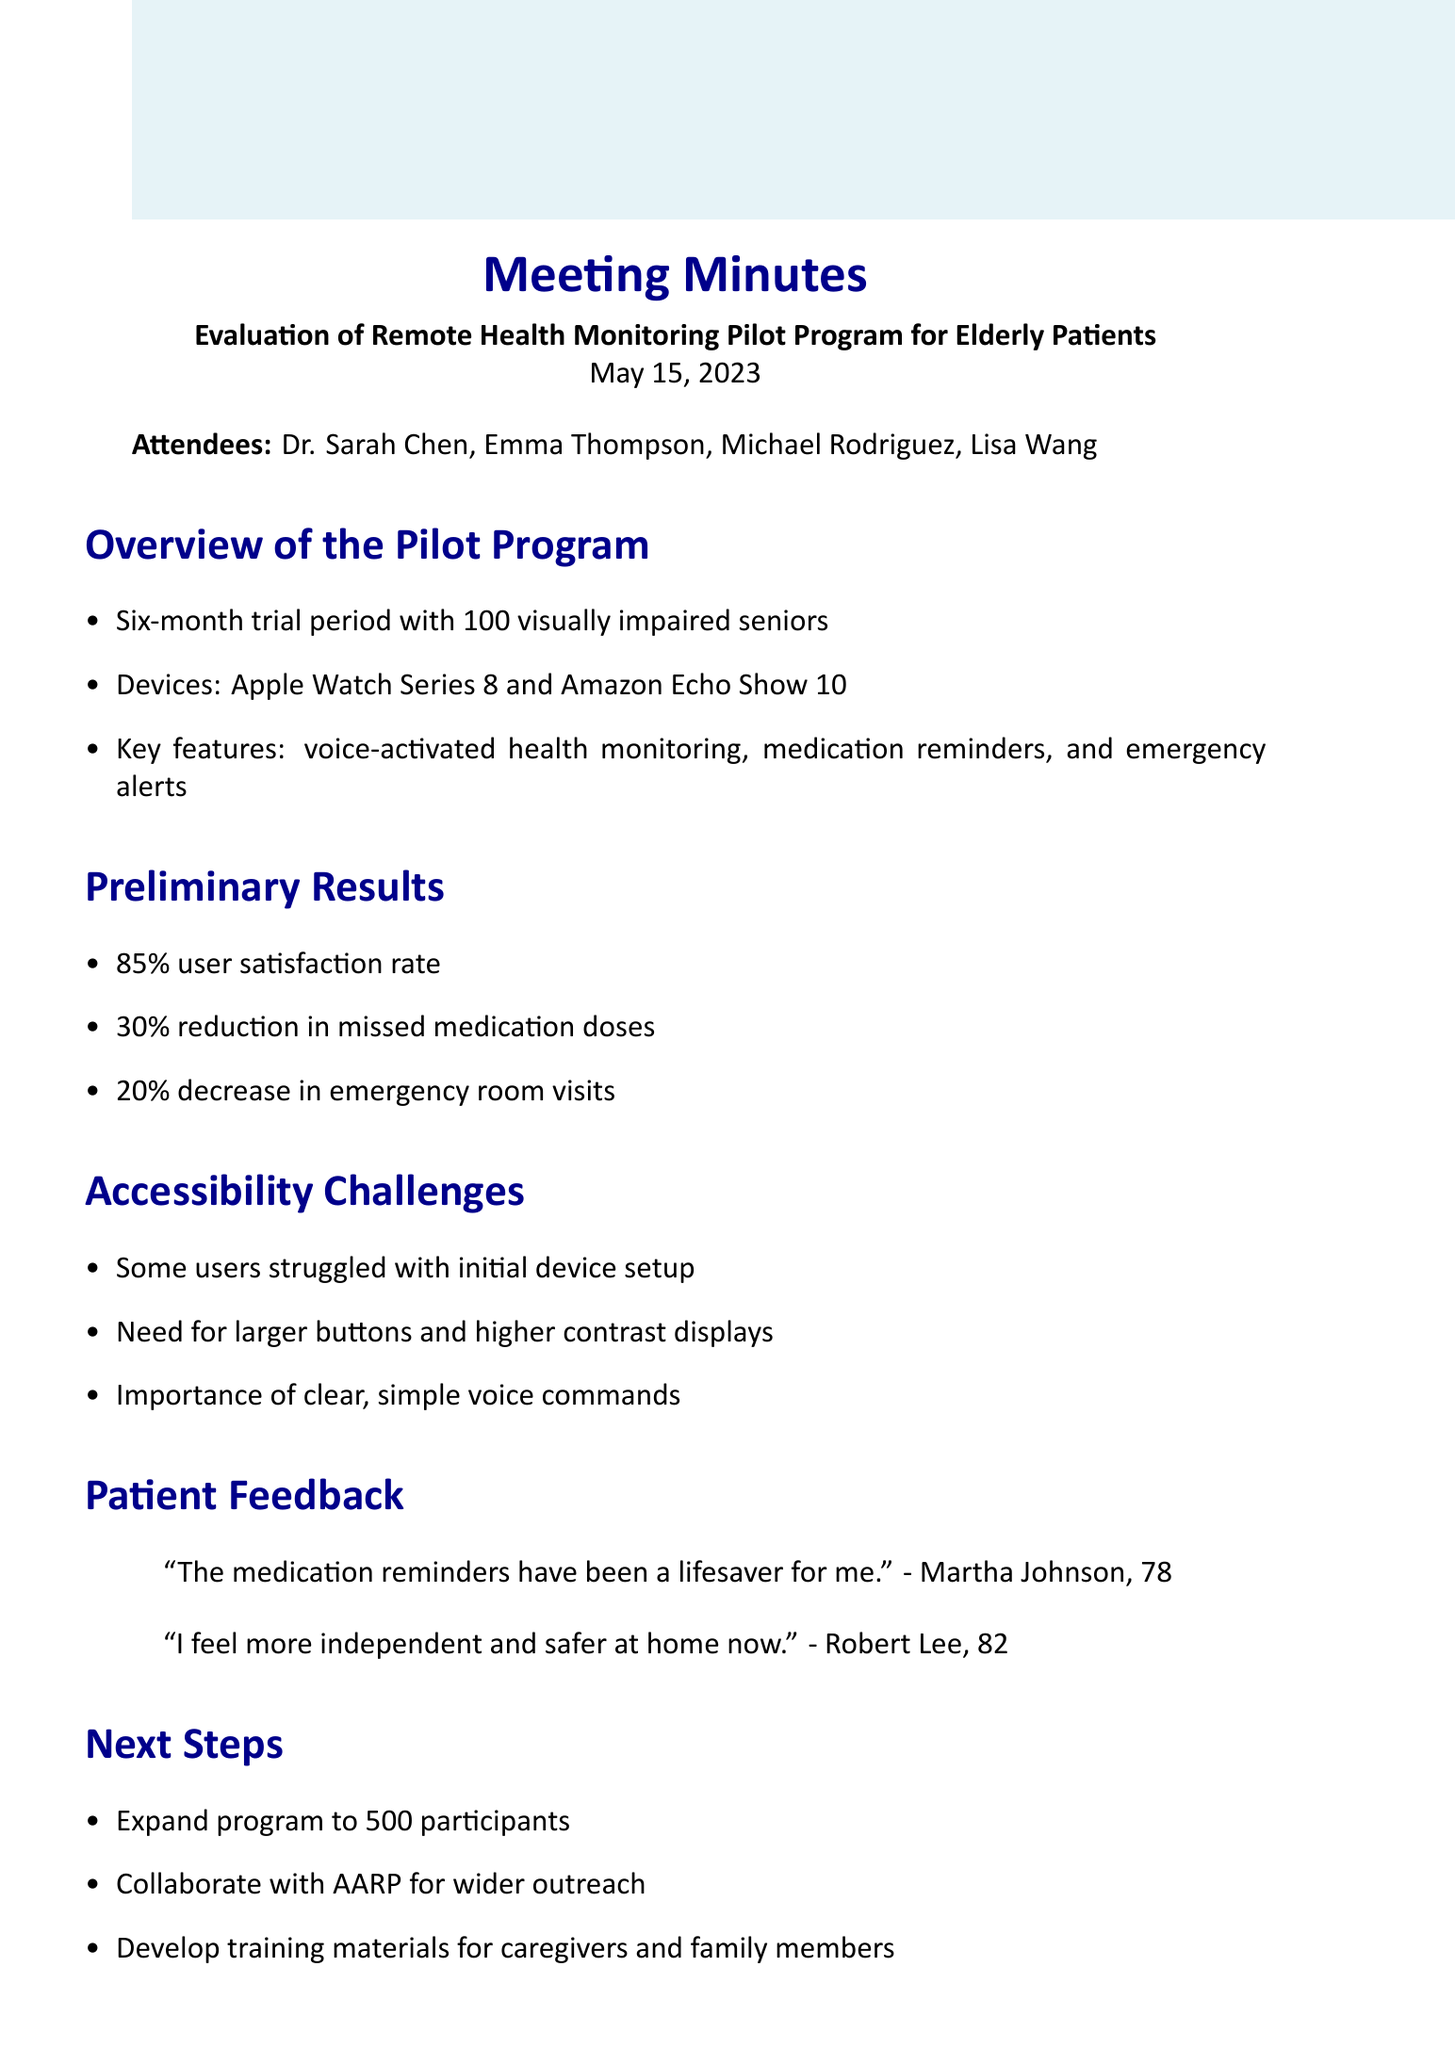What is the date of the meeting? The date of the meeting is mentioned clearly at the beginning of the document.
Answer: May 15, 2023 How many seniors participated in the pilot program? This information can be found in the overview section of the document.
Answer: 100 What devices were used in the pilot program? The document lists the devices tested during the pilot program in the overview section.
Answer: Apple Watch Series 8 and Amazon Echo Show 10 What percentage of users reported satisfaction? This statistic is included in the preliminary results section of the document.
Answer: 85% What is one of the accessibility challenges mentioned? The challenges discussed are listed under the accessibility challenges section in the document.
Answer: Some users struggled with initial device setup Who is responsible for drafting accessibility improvement recommendations? The action items section specifies who is assigned to each task.
Answer: Lisa What is the next step regarding program expansion? The document outlines future plans in the next steps section.
Answer: Expand program to 500 participants Which organization will be collaborated with for wider outreach? The next steps mention collaborations intended for outreach.
Answer: AARP 